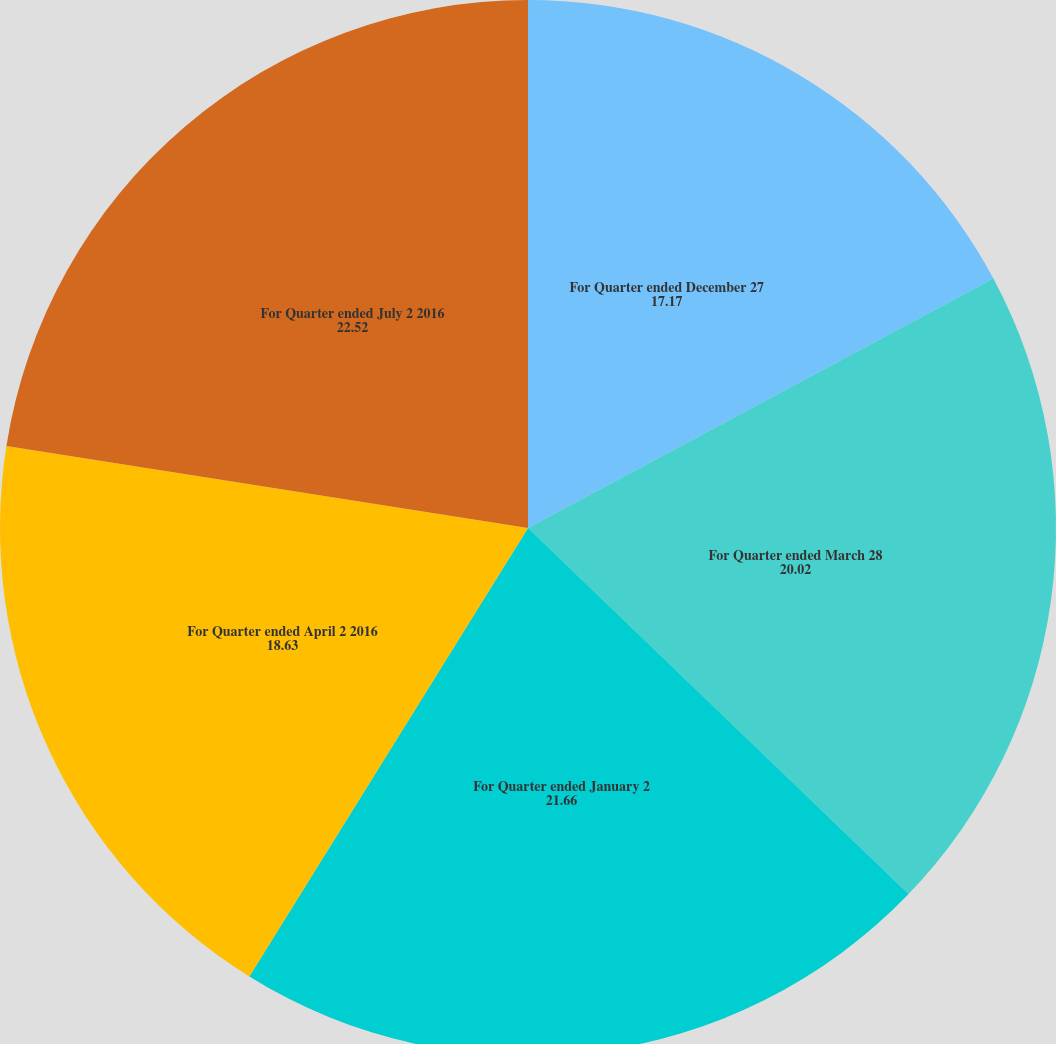Convert chart. <chart><loc_0><loc_0><loc_500><loc_500><pie_chart><fcel>For Quarter ended December 27<fcel>For Quarter ended March 28<fcel>For Quarter ended January 2<fcel>For Quarter ended April 2 2016<fcel>For Quarter ended July 2 2016<nl><fcel>17.17%<fcel>20.02%<fcel>21.66%<fcel>18.63%<fcel>22.52%<nl></chart> 